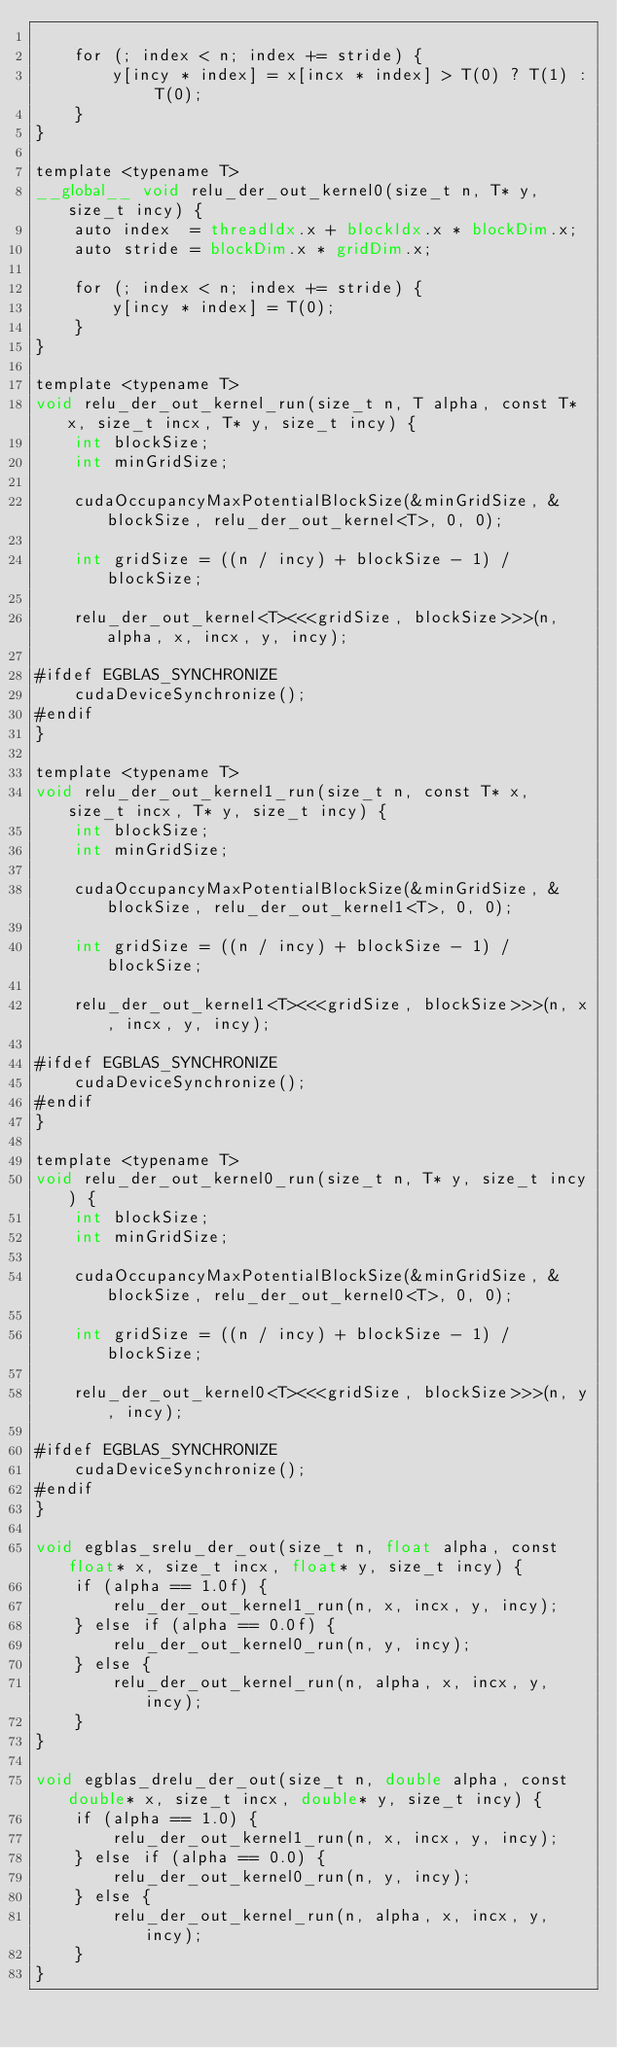Convert code to text. <code><loc_0><loc_0><loc_500><loc_500><_Cuda_>
    for (; index < n; index += stride) {
        y[incy * index] = x[incx * index] > T(0) ? T(1) : T(0);
    }
}

template <typename T>
__global__ void relu_der_out_kernel0(size_t n, T* y, size_t incy) {
    auto index  = threadIdx.x + blockIdx.x * blockDim.x;
    auto stride = blockDim.x * gridDim.x;

    for (; index < n; index += stride) {
        y[incy * index] = T(0);
    }
}

template <typename T>
void relu_der_out_kernel_run(size_t n, T alpha, const T* x, size_t incx, T* y, size_t incy) {
    int blockSize;
    int minGridSize;

    cudaOccupancyMaxPotentialBlockSize(&minGridSize, &blockSize, relu_der_out_kernel<T>, 0, 0);

    int gridSize = ((n / incy) + blockSize - 1) / blockSize;

    relu_der_out_kernel<T><<<gridSize, blockSize>>>(n, alpha, x, incx, y, incy);

#ifdef EGBLAS_SYNCHRONIZE
    cudaDeviceSynchronize();
#endif
}

template <typename T>
void relu_der_out_kernel1_run(size_t n, const T* x, size_t incx, T* y, size_t incy) {
    int blockSize;
    int minGridSize;

    cudaOccupancyMaxPotentialBlockSize(&minGridSize, &blockSize, relu_der_out_kernel1<T>, 0, 0);

    int gridSize = ((n / incy) + blockSize - 1) / blockSize;

    relu_der_out_kernel1<T><<<gridSize, blockSize>>>(n, x, incx, y, incy);

#ifdef EGBLAS_SYNCHRONIZE
    cudaDeviceSynchronize();
#endif
}

template <typename T>
void relu_der_out_kernel0_run(size_t n, T* y, size_t incy) {
    int blockSize;
    int minGridSize;

    cudaOccupancyMaxPotentialBlockSize(&minGridSize, &blockSize, relu_der_out_kernel0<T>, 0, 0);

    int gridSize = ((n / incy) + blockSize - 1) / blockSize;

    relu_der_out_kernel0<T><<<gridSize, blockSize>>>(n, y, incy);

#ifdef EGBLAS_SYNCHRONIZE
    cudaDeviceSynchronize();
#endif
}

void egblas_srelu_der_out(size_t n, float alpha, const float* x, size_t incx, float* y, size_t incy) {
    if (alpha == 1.0f) {
        relu_der_out_kernel1_run(n, x, incx, y, incy);
    } else if (alpha == 0.0f) {
        relu_der_out_kernel0_run(n, y, incy);
    } else {
        relu_der_out_kernel_run(n, alpha, x, incx, y, incy);
    }
}

void egblas_drelu_der_out(size_t n, double alpha, const double* x, size_t incx, double* y, size_t incy) {
    if (alpha == 1.0) {
        relu_der_out_kernel1_run(n, x, incx, y, incy);
    } else if (alpha == 0.0) {
        relu_der_out_kernel0_run(n, y, incy);
    } else {
        relu_der_out_kernel_run(n, alpha, x, incx, y, incy);
    }
}
</code> 